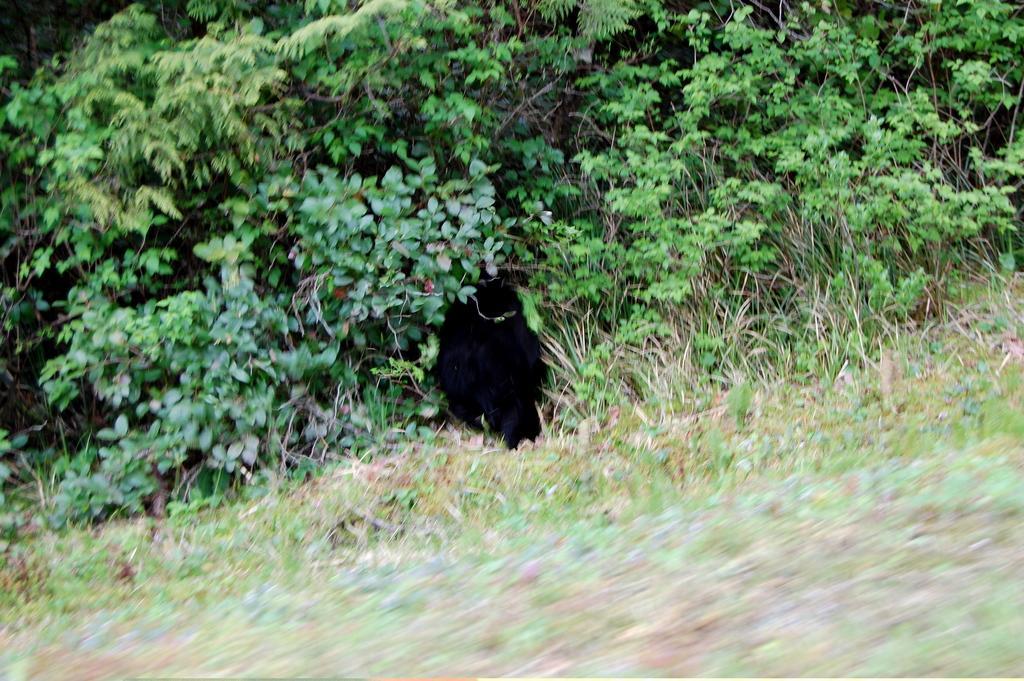Could you give a brief overview of what you see in this image? In this picture I can see the plants and grass. In the center there is a black hole. On the left I can see the leaves. 